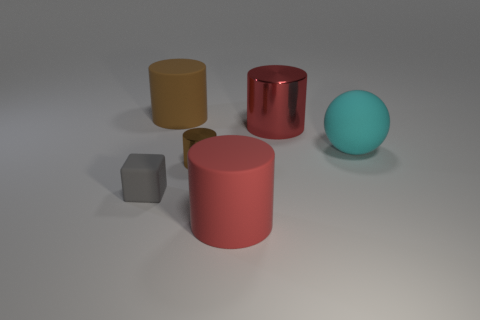If I were to arrange these objects from left to right based on their reflective quality, what would the order be? If we are to arrange the objects based on their reflectiveness from left to right, the order would be: the yellow cylinder, which has the least reflective surface, next the gray cube, then the red cylindrical object with a polished, reflective surface, and finally the blue sphere, which also appears to have a somewhat reflective surface but less so than the red cylinder. 